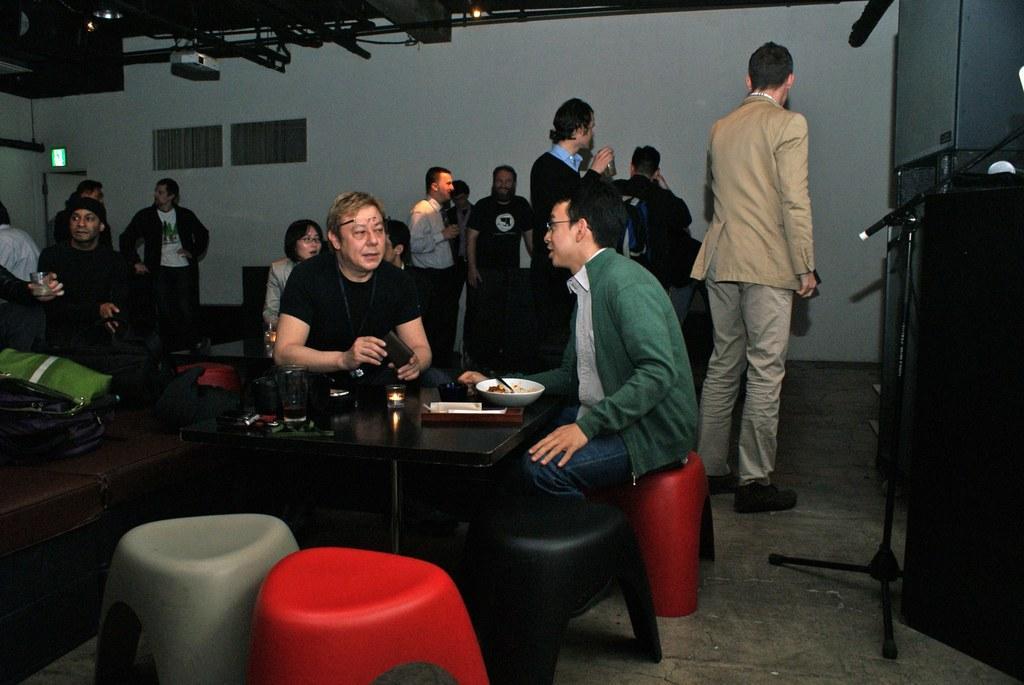Can you describe this image briefly? This picture is clicked in a room. There are group of persons in the room. In the center there are two people sitting besides a table. On the table there is a bowl, glass and a tray. To the bottom left there are two chairs. In the background there there are group of people and a wall. 